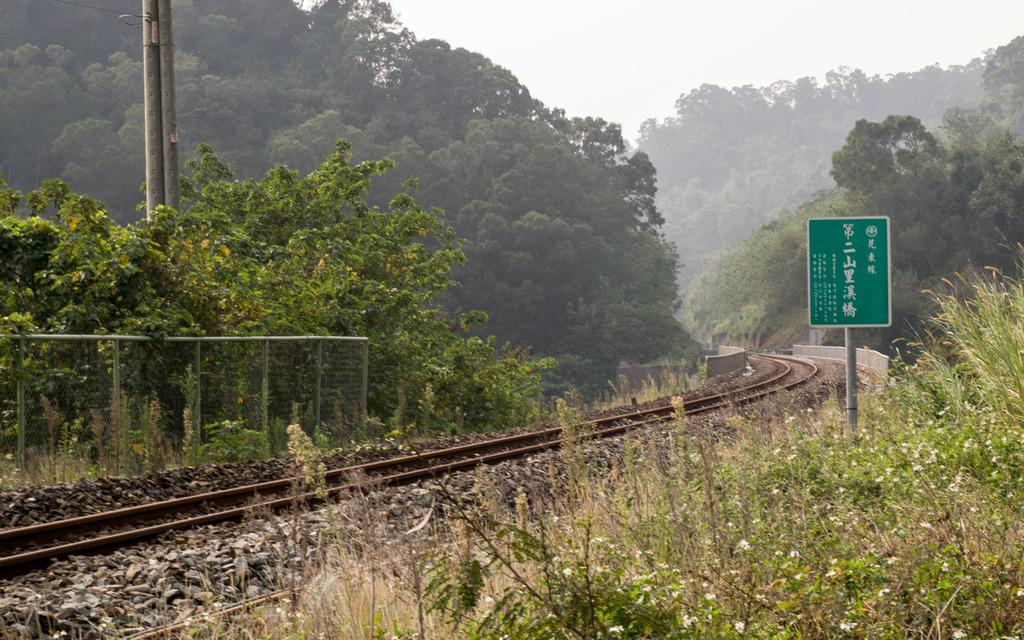What is the main feature in the image? There is a track in the image. What is located to the right of the track? There is a green color board to the right of the track. What is located to the left of the track? There is a railing to the left of the track. What can be seen in the background of the image? There are many trees and the sky visible in the background of the image. Can you tell me who won the fight in the image? There is no fight present in the image; it features a track, a green color board, a railing, trees, and the sky. What type of riddle can be seen on the track in the image? There is no riddle present on the track in the image; it is a physical structure for vehicles or people to move along. 